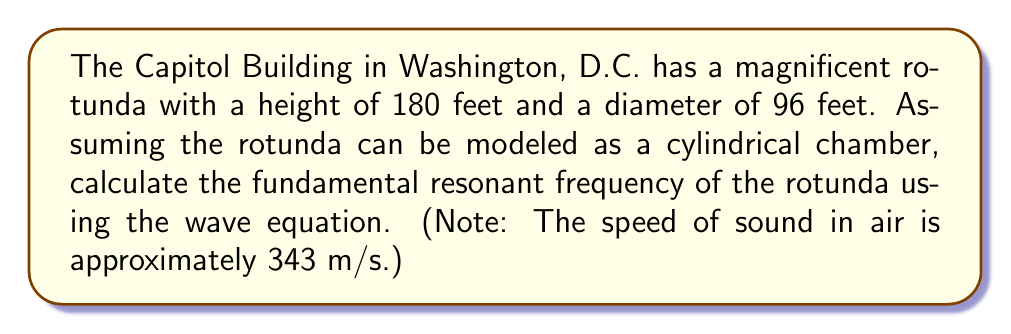Help me with this question. To solve this problem, we'll use the wave equation for a cylindrical chamber. The fundamental resonant frequency of a cylindrical room is given by:

$$f = \frac{c}{2} \sqrt{\left(\frac{1}{L}\right)^2 + \left(\frac{j_{01}}{a\pi}\right)^2}$$

Where:
$f$ is the fundamental resonant frequency
$c$ is the speed of sound in air (343 m/s)
$L$ is the height of the cylinder
$a$ is the radius of the cylinder
$j_{01}$ is the first zero of the Bessel function of the first kind (approximately 2.405)

Step 1: Convert the given dimensions to meters.
Height: $L = 180 \text{ feet} \times 0.3048 \text{ m/ft} = 54.864 \text{ m}$
Diameter: $96 \text{ feet} \times 0.3048 \text{ m/ft} = 29.2608 \text{ m}$
Radius: $a = 29.2608 \text{ m} \div 2 = 14.6304 \text{ m}$

Step 2: Substitute the values into the equation.

$$f = \frac{343}{2} \sqrt{\left(\frac{1}{54.864}\right)^2 + \left(\frac{2.405}{14.6304\pi}\right)^2}$$

Step 3: Simplify and calculate.

$$f = 171.5 \sqrt{(0.01823)^2 + (0.05233)^2}$$
$$f = 171.5 \sqrt{0.000332 + 0.002738}$$
$$f = 171.5 \sqrt{0.00307}$$
$$f = 171.5 \times 0.05541$$
$$f = 9.503 \text{ Hz}$$

Therefore, the fundamental resonant frequency of the Capitol Building's rotunda is approximately 9.503 Hz.
Answer: 9.503 Hz 